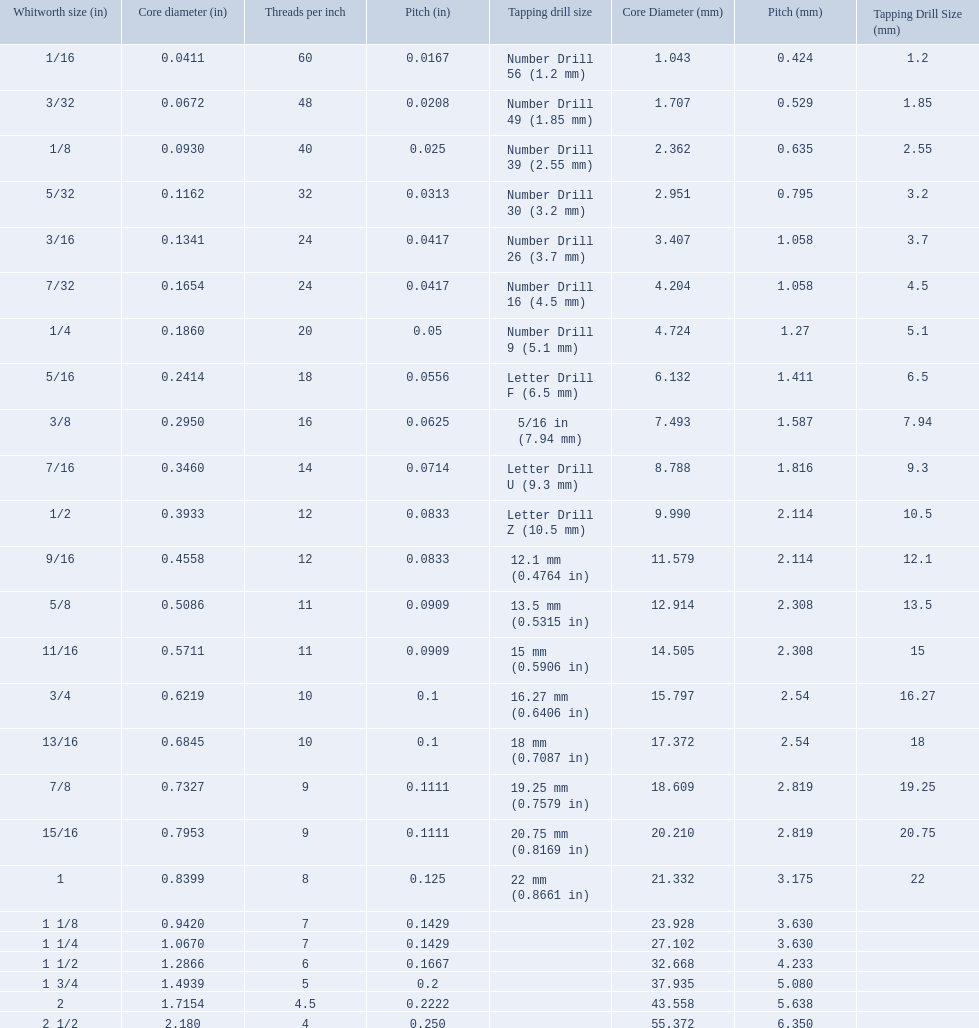What are the whitworth sizes? 1/16, 3/32, 1/8, 5/32, 3/16, 7/32, 1/4, 5/16, 3/8, 7/16, 1/2, 9/16, 5/8, 11/16, 3/4, 13/16, 7/8, 15/16, 1, 1 1/8, 1 1/4, 1 1/2, 1 3/4, 2, 2 1/2. And their threads per inch? 60, 48, 40, 32, 24, 24, 20, 18, 16, 14, 12, 12, 11, 11, 10, 10, 9, 9, 8, 7, 7, 6, 5, 4.5, 4. Now, which whitworth size has a thread-per-inch size of 5?? 1 3/4. 